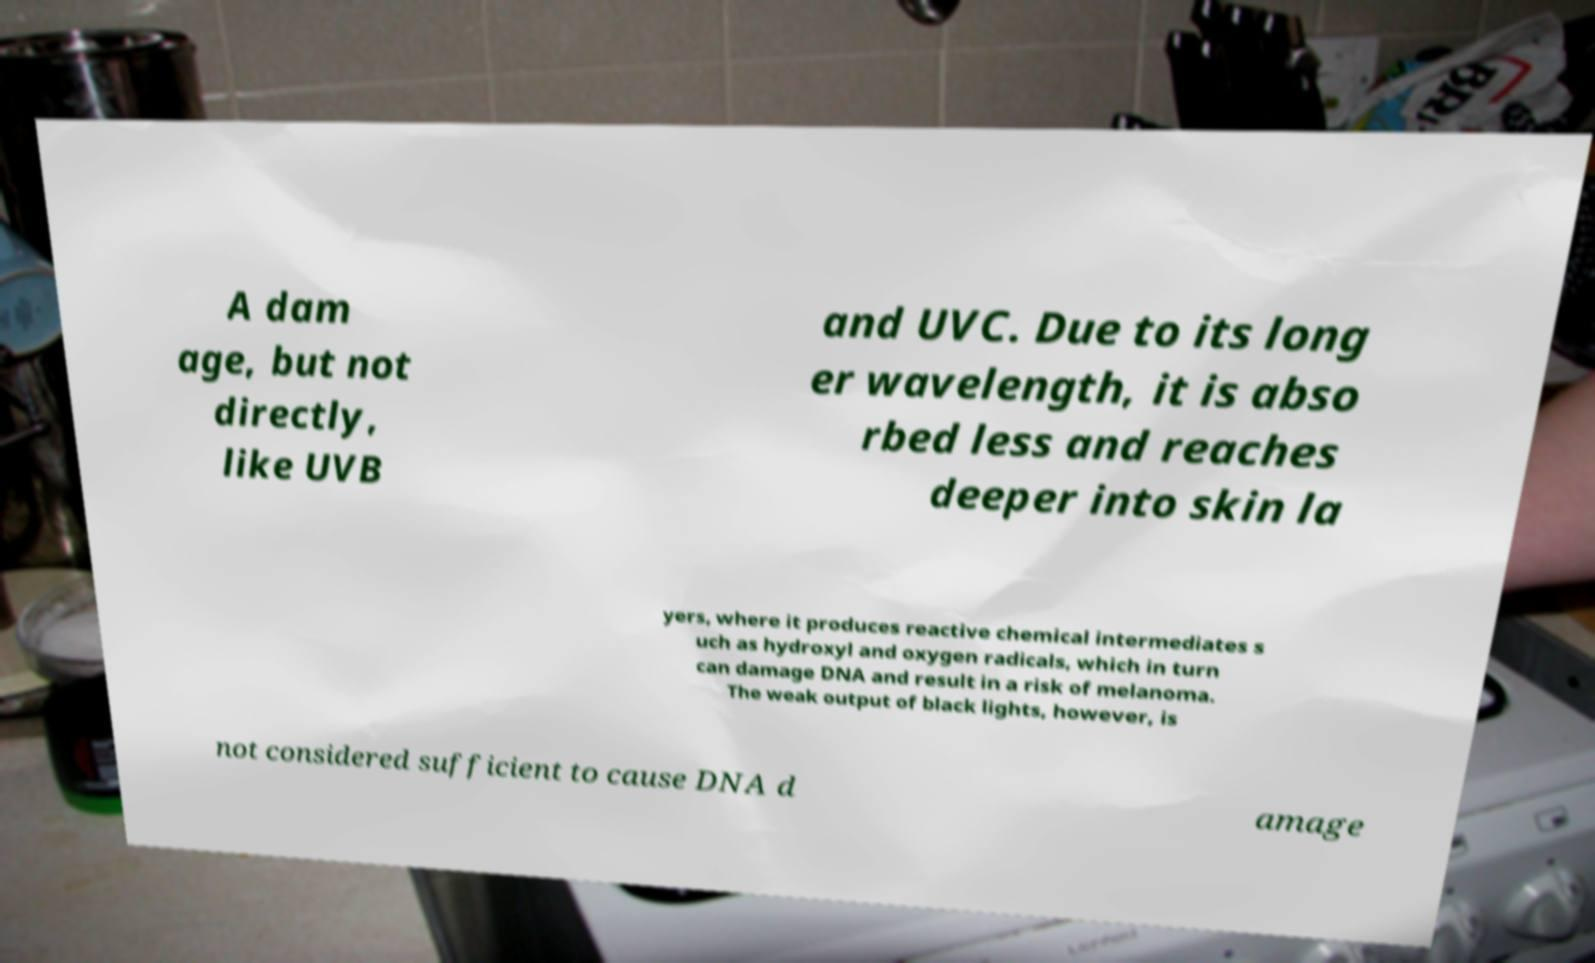There's text embedded in this image that I need extracted. Can you transcribe it verbatim? A dam age, but not directly, like UVB and UVC. Due to its long er wavelength, it is abso rbed less and reaches deeper into skin la yers, where it produces reactive chemical intermediates s uch as hydroxyl and oxygen radicals, which in turn can damage DNA and result in a risk of melanoma. The weak output of black lights, however, is not considered sufficient to cause DNA d amage 